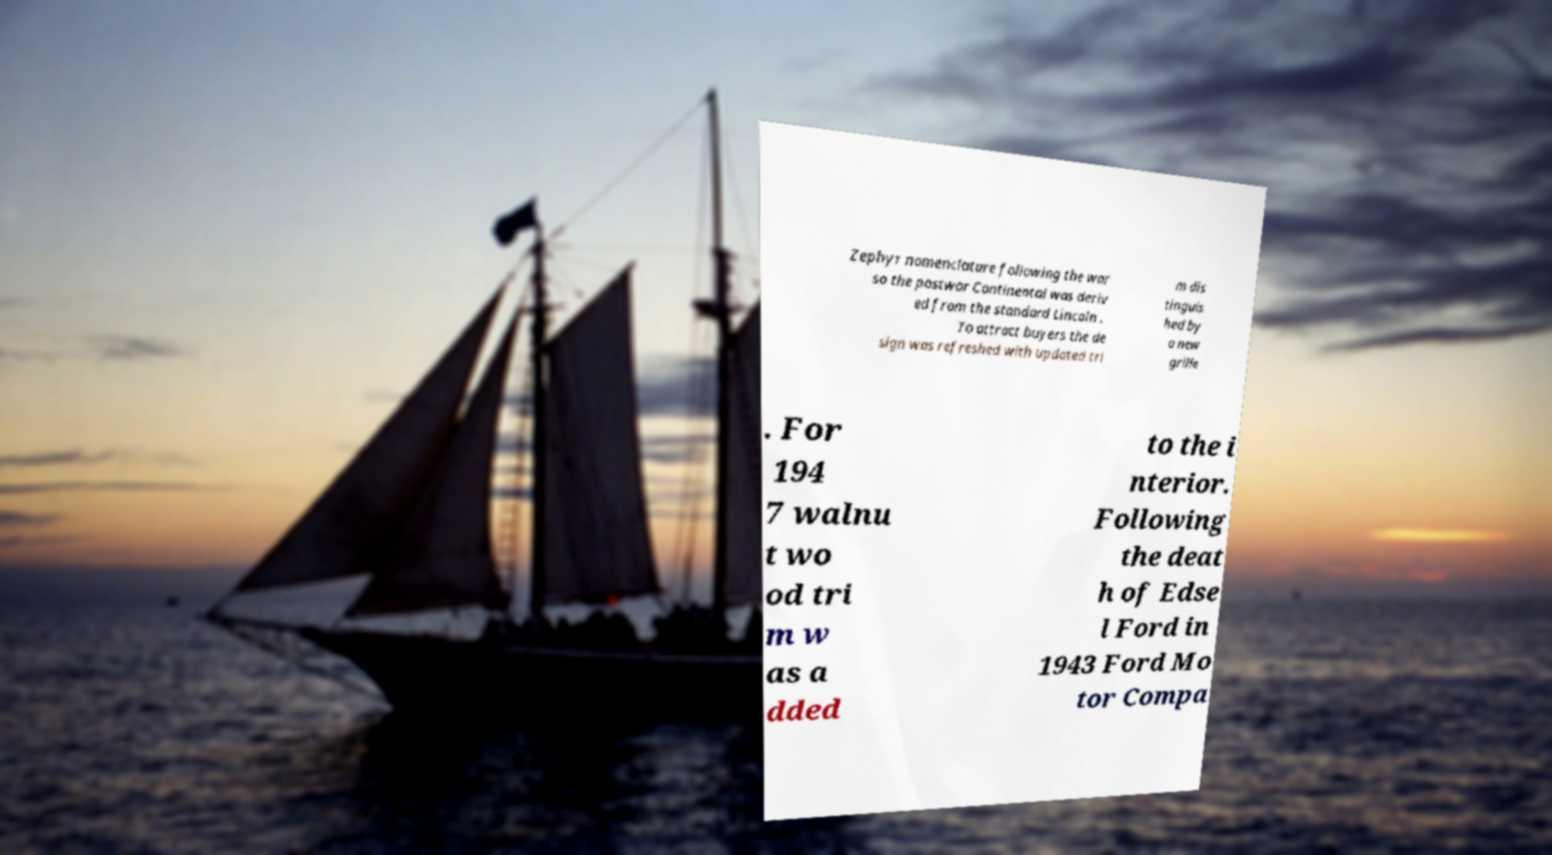Please identify and transcribe the text found in this image. Zephyr nomenclature following the war so the postwar Continental was deriv ed from the standard Lincoln . To attract buyers the de sign was refreshed with updated tri m dis tinguis hed by a new grille . For 194 7 walnu t wo od tri m w as a dded to the i nterior. Following the deat h of Edse l Ford in 1943 Ford Mo tor Compa 